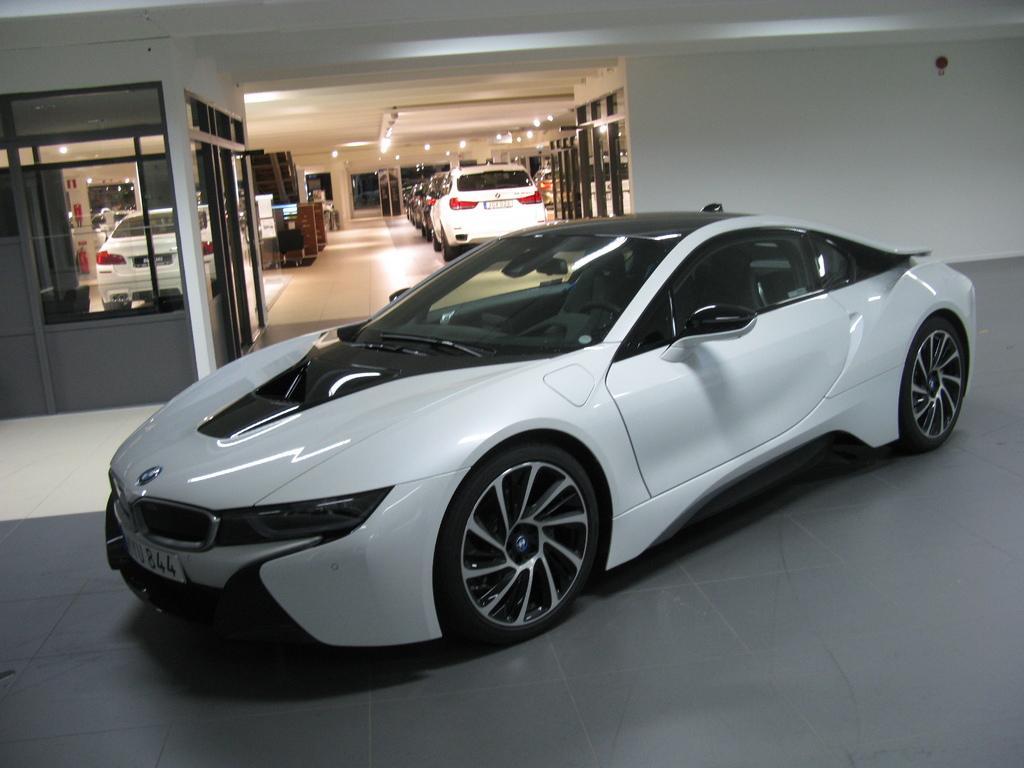How would you summarize this image in a sentence or two? In this picture I can observe a car in the middle of the picture. In the background there are some cars in the showroom. I can observe some lights fixed to the ceiling. On the right side I can observe wall. 